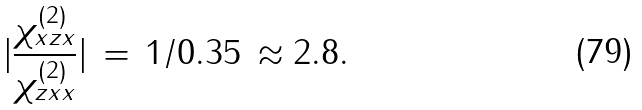<formula> <loc_0><loc_0><loc_500><loc_500>| \frac { \chi _ { x z x } ^ { ( 2 ) } } { \chi _ { z x x } ^ { ( 2 ) } } | \, = \, 1 / 0 . 3 5 \, \approx 2 . 8 .</formula> 